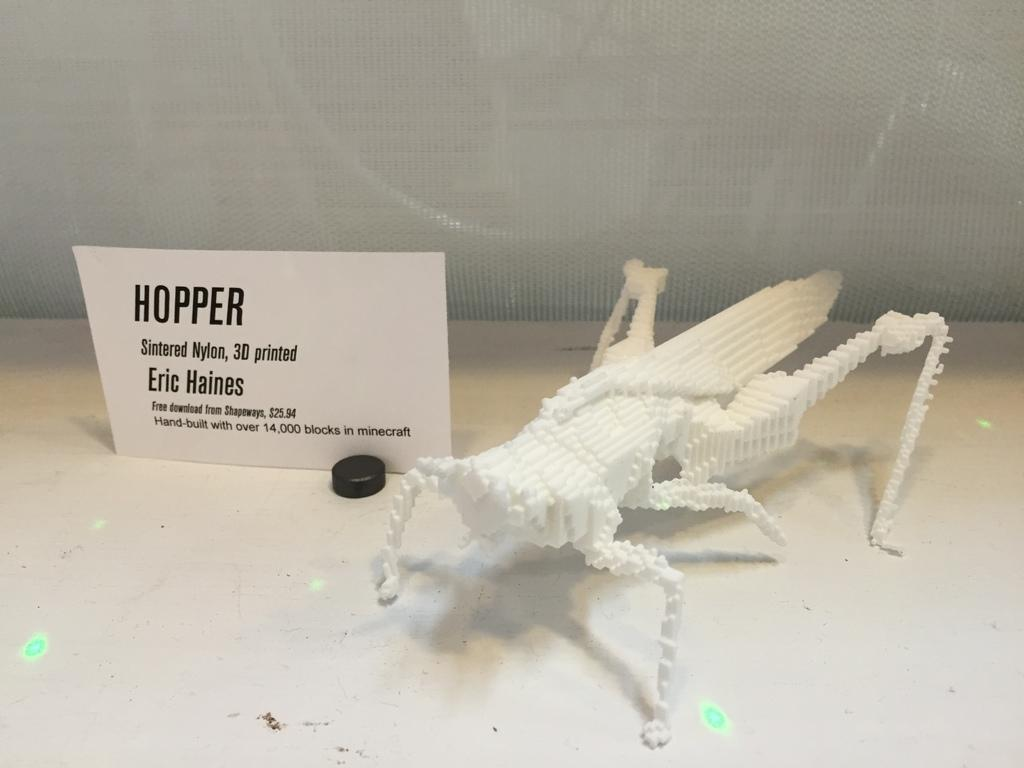What material is the hopper made of in the image? The hopper is made up of thermocool in the image. What other object can be seen in the image? There is a paper board in the image. What is visible in the background of the image? There is a net in the background of the image. What type of scarf is being worn by the hopper in the image? There is no scarf present in the image, as the subject is a hopper made of thermocool. Can you see any army personnel in the image? There is no reference to any army personnel in the image; it features a hopper, a paper board, and a net in the background. 